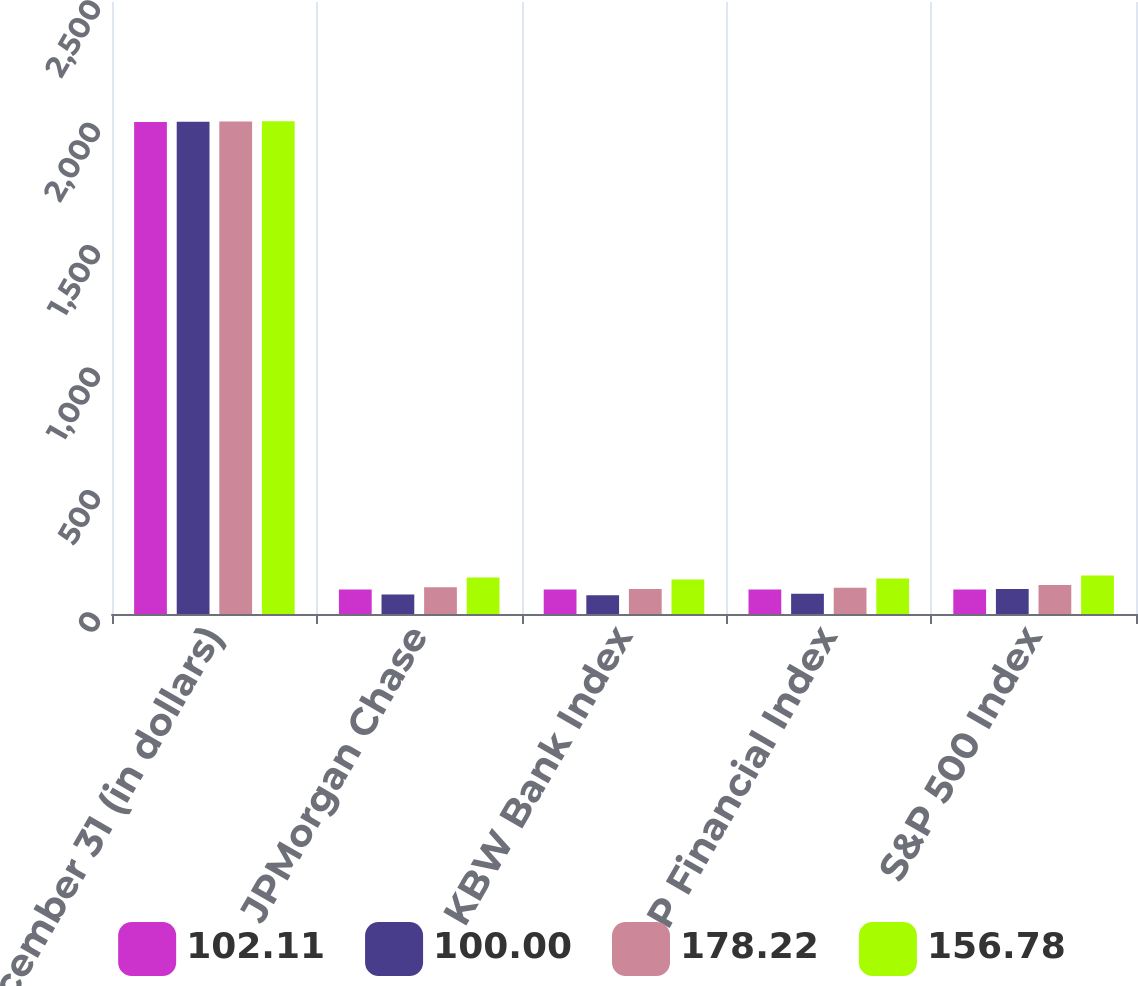Convert chart. <chart><loc_0><loc_0><loc_500><loc_500><stacked_bar_chart><ecel><fcel>December 31 (in dollars)<fcel>JPMorgan Chase<fcel>KBW Bank Index<fcel>S&P Financial Index<fcel>S&P 500 Index<nl><fcel>102.11<fcel>2010<fcel>100<fcel>100<fcel>100<fcel>100<nl><fcel>100<fcel>2011<fcel>80.03<fcel>76.82<fcel>82.94<fcel>102.11<nl><fcel>178.22<fcel>2012<fcel>108.98<fcel>102.19<fcel>106.78<fcel>118.44<nl><fcel>156.78<fcel>2013<fcel>148.98<fcel>140.77<fcel>144.79<fcel>156.78<nl></chart> 